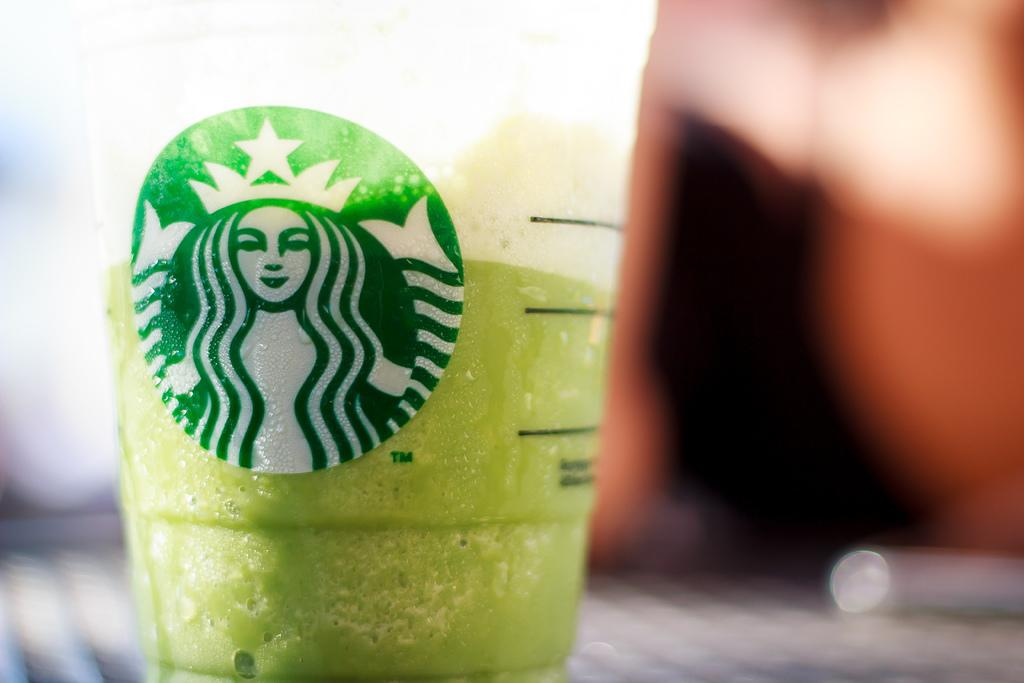What is in the glass that is visible in the image? There is a green liquid in a glass in the image. What decoration is on the glass? There is a sketch of a woman on the glass. Can you describe the background of the image? The background of the image is blurry. What type of dust can be seen settling on the tin in the image? There is no tin or dust present in the image; it only features a glass with a green liquid and a sketch of a woman. 